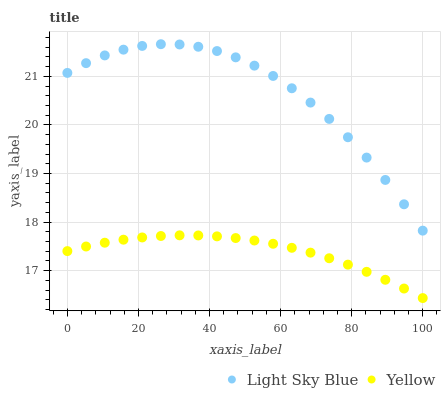Does Yellow have the minimum area under the curve?
Answer yes or no. Yes. Does Light Sky Blue have the maximum area under the curve?
Answer yes or no. Yes. Does Yellow have the maximum area under the curve?
Answer yes or no. No. Is Yellow the smoothest?
Answer yes or no. Yes. Is Light Sky Blue the roughest?
Answer yes or no. Yes. Is Yellow the roughest?
Answer yes or no. No. Does Yellow have the lowest value?
Answer yes or no. Yes. Does Light Sky Blue have the highest value?
Answer yes or no. Yes. Does Yellow have the highest value?
Answer yes or no. No. Is Yellow less than Light Sky Blue?
Answer yes or no. Yes. Is Light Sky Blue greater than Yellow?
Answer yes or no. Yes. Does Yellow intersect Light Sky Blue?
Answer yes or no. No. 